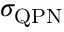<formula> <loc_0><loc_0><loc_500><loc_500>\sigma _ { Q P N }</formula> 